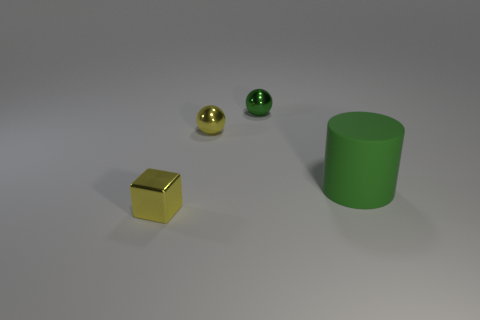How many objects are gray metallic spheres or yellow shiny spheres to the left of the big green cylinder? In the image, there is one yellow shiny cube present to the left of the big green cylinder. There are no gray metallic spheres or any spherical objects identified as yellow and shiny in that particular location. Therefore, the answer to your question is zero. 